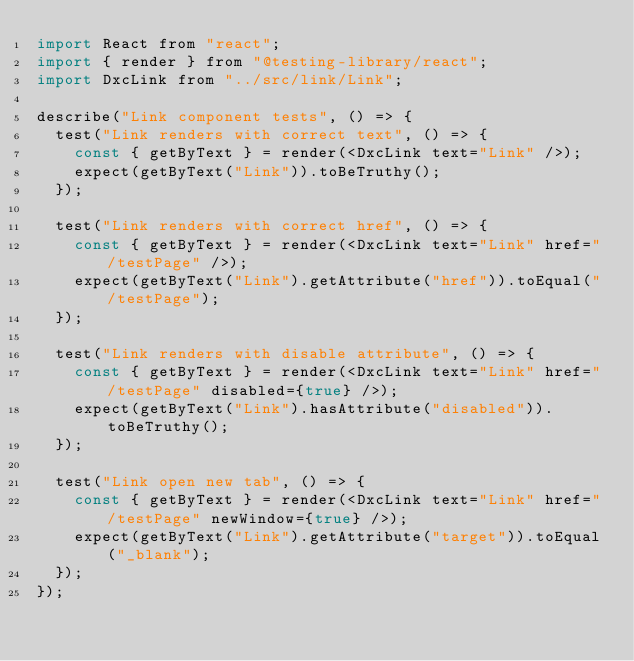Convert code to text. <code><loc_0><loc_0><loc_500><loc_500><_JavaScript_>import React from "react";
import { render } from "@testing-library/react";
import DxcLink from "../src/link/Link";

describe("Link component tests", () => {
  test("Link renders with correct text", () => {
    const { getByText } = render(<DxcLink text="Link" />);
    expect(getByText("Link")).toBeTruthy();
  });

  test("Link renders with correct href", () => {
    const { getByText } = render(<DxcLink text="Link" href="/testPage" />);
    expect(getByText("Link").getAttribute("href")).toEqual("/testPage");
  });

  test("Link renders with disable attribute", () => {
    const { getByText } = render(<DxcLink text="Link" href="/testPage" disabled={true} />);
    expect(getByText("Link").hasAttribute("disabled")).toBeTruthy();
  });

  test("Link open new tab", () => {
    const { getByText } = render(<DxcLink text="Link" href="/testPage" newWindow={true} />);
    expect(getByText("Link").getAttribute("target")).toEqual("_blank");
  });
});
</code> 